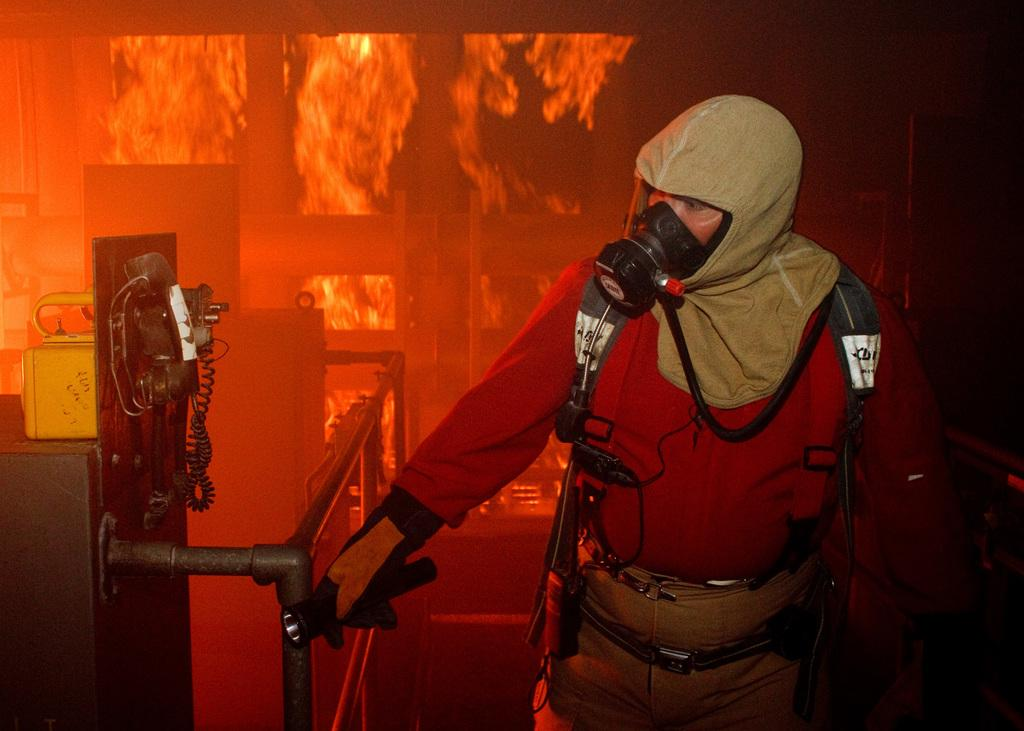Who is present in the image? There is a man in the image. What is the man doing in the image? The man is standing and holding a torch. What is the man wearing in the image? The man is wearing a mask. What can be seen in the background of the image? There is fire visible in the background of the image. What scene is being copied in the image? There is no indication in the image that a scene is being copied. 